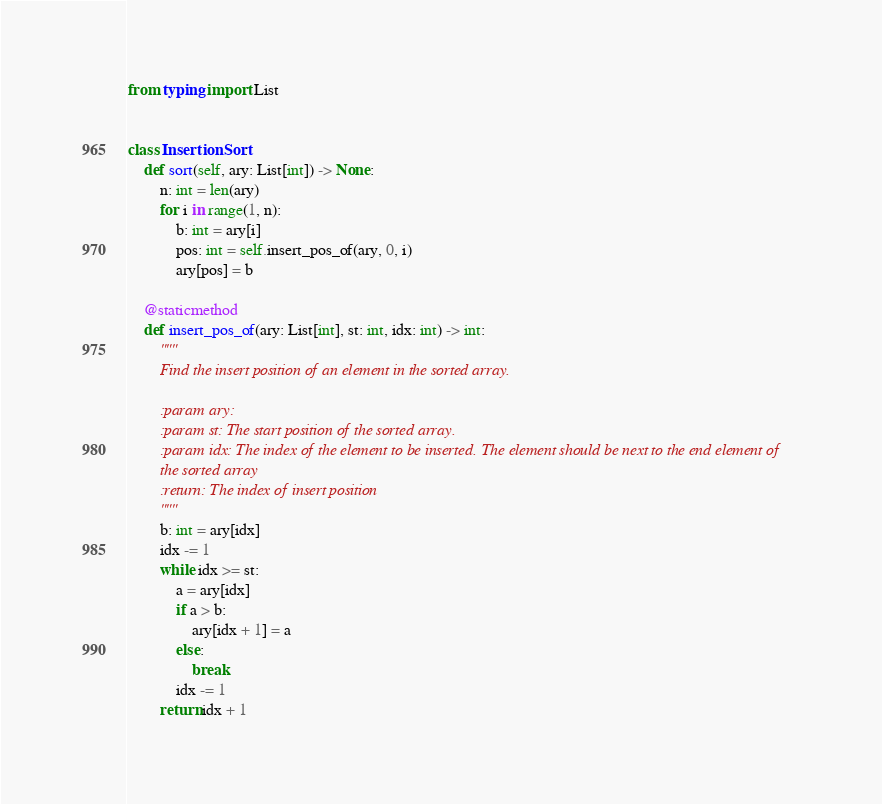<code> <loc_0><loc_0><loc_500><loc_500><_Python_>from typing import List


class InsertionSort:
    def sort(self, ary: List[int]) -> None:
        n: int = len(ary)
        for i in range(1, n):
            b: int = ary[i]
            pos: int = self.insert_pos_of(ary, 0, i)
            ary[pos] = b

    @staticmethod
    def insert_pos_of(ary: List[int], st: int, idx: int) -> int:
        """
        Find the insert position of an element in the sorted array.

        :param ary:
        :param st: The start position of the sorted array.
        :param idx: The index of the element to be inserted. The element should be next to the end element of
        the sorted array
        :return: The index of insert position
        """
        b: int = ary[idx]
        idx -= 1
        while idx >= st:
            a = ary[idx]
            if a > b:
                ary[idx + 1] = a
            else:
                break
            idx -= 1
        return idx + 1
</code> 